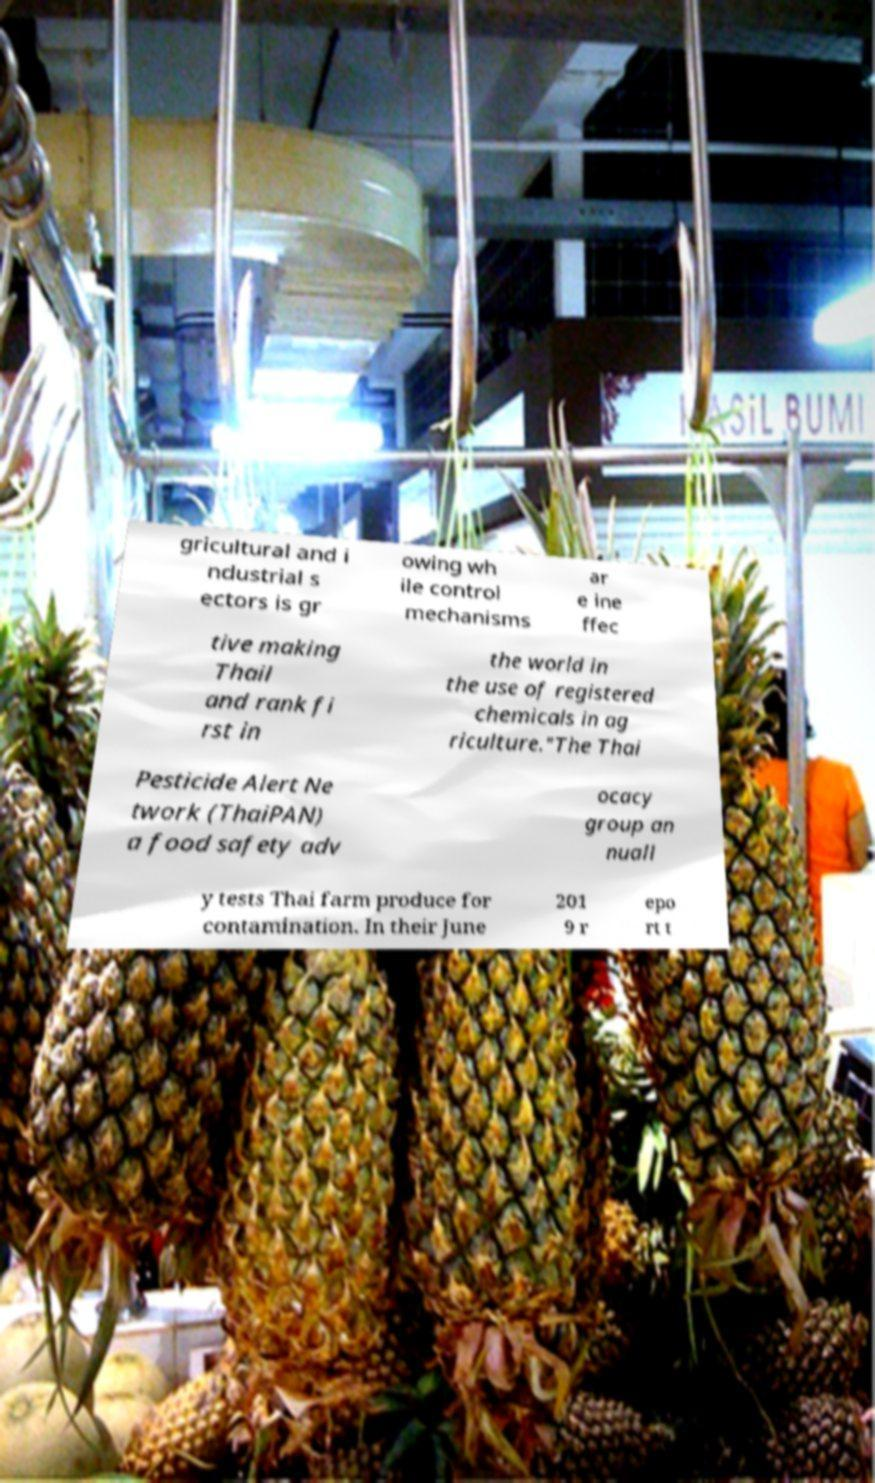Please read and relay the text visible in this image. What does it say? gricultural and i ndustrial s ectors is gr owing wh ile control mechanisms ar e ine ffec tive making Thail and rank fi rst in the world in the use of registered chemicals in ag riculture."The Thai Pesticide Alert Ne twork (ThaiPAN) a food safety adv ocacy group an nuall y tests Thai farm produce for contamination. In their June 201 9 r epo rt t 